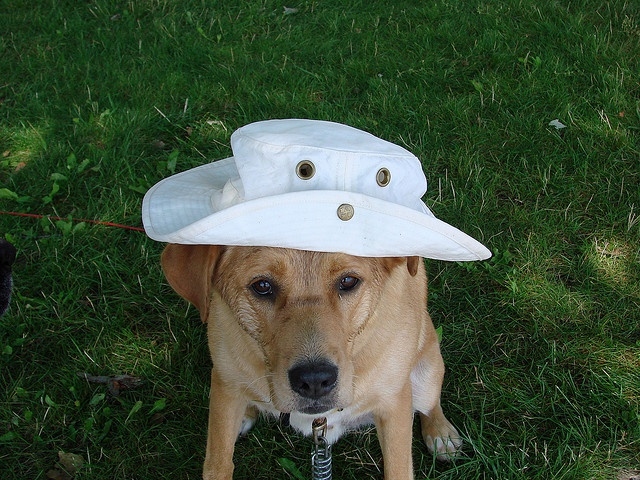Describe the objects in this image and their specific colors. I can see a dog in black, gray, darkgray, and tan tones in this image. 